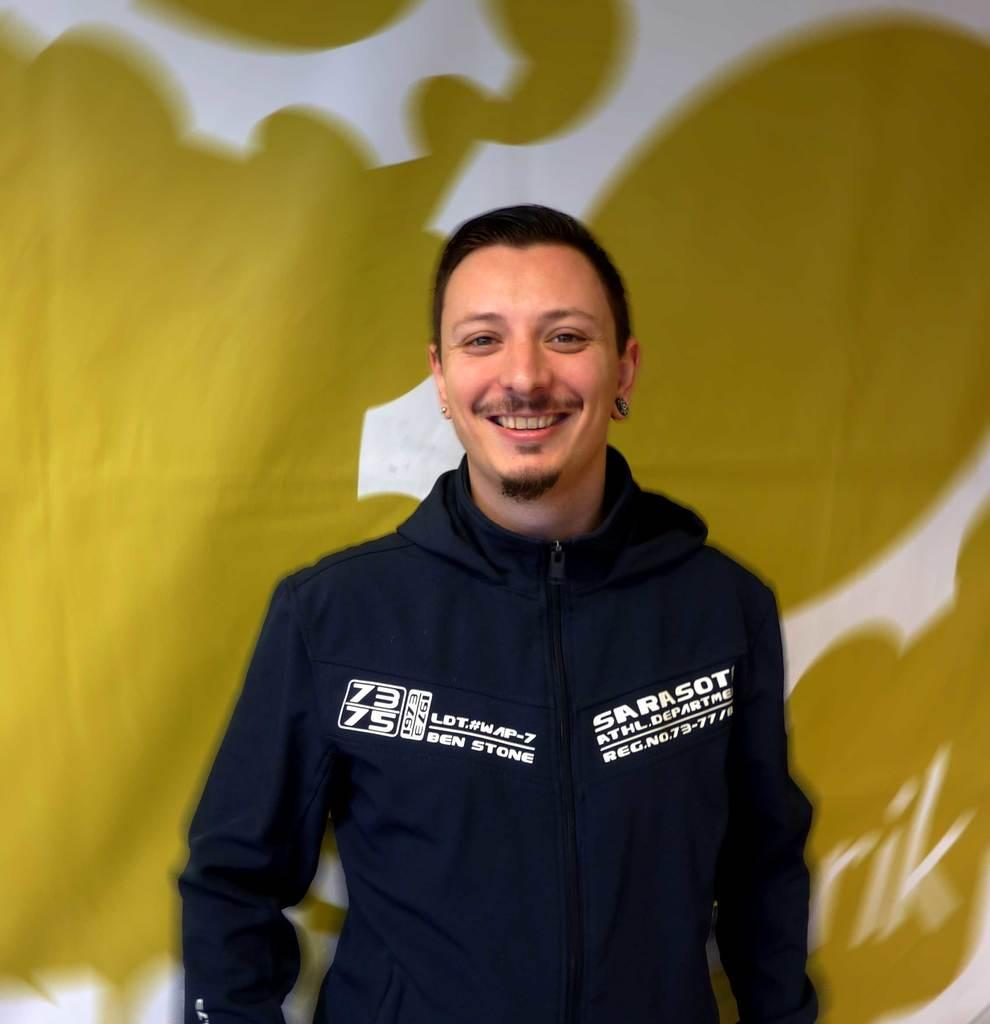<image>
Create a compact narrative representing the image presented. A man smiles at the camera wearing a blue hoody with Ben Stone and Sarasot written on it in white. 